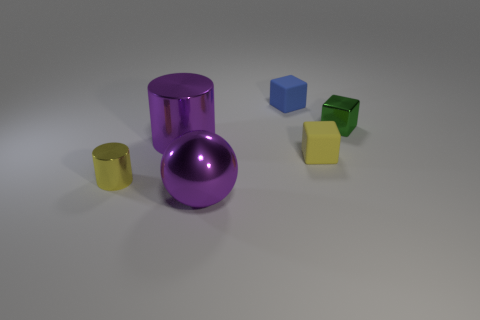Subtract all tiny rubber blocks. How many blocks are left? 1 Add 1 tiny yellow cylinders. How many objects exist? 7 Subtract all tiny yellow metal cubes. Subtract all metal balls. How many objects are left? 5 Add 5 blue blocks. How many blue blocks are left? 6 Add 3 tiny green things. How many tiny green things exist? 4 Subtract 0 green cylinders. How many objects are left? 6 Subtract all cylinders. How many objects are left? 4 